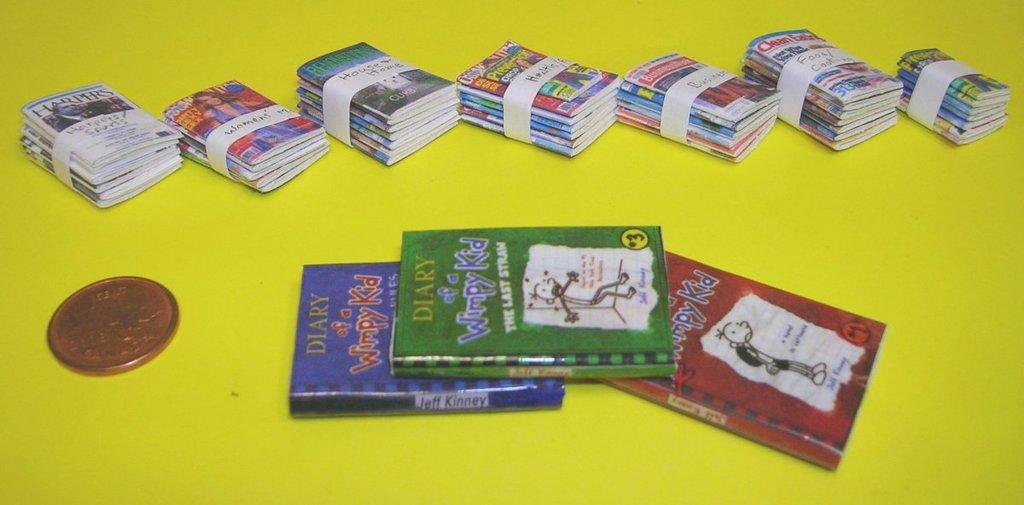<image>
Present a compact description of the photo's key features. Three books sit on a yellow table about the diary of a whimpy kid. 